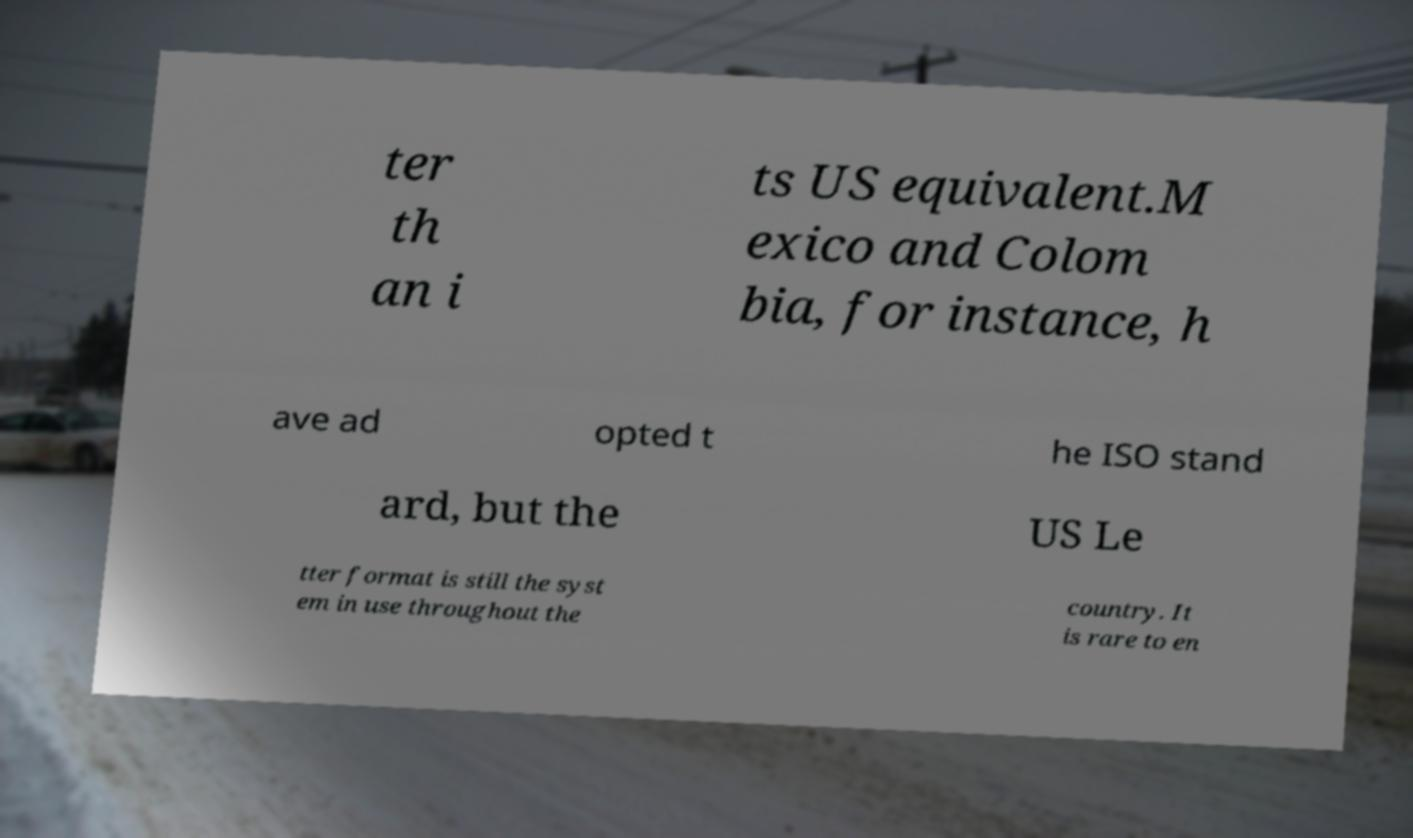What messages or text are displayed in this image? I need them in a readable, typed format. ter th an i ts US equivalent.M exico and Colom bia, for instance, h ave ad opted t he ISO stand ard, but the US Le tter format is still the syst em in use throughout the country. It is rare to en 